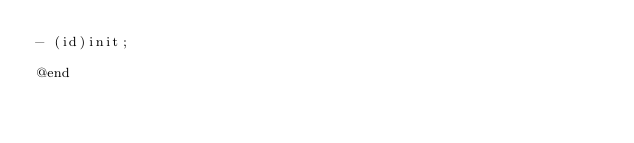Convert code to text. <code><loc_0><loc_0><loc_500><loc_500><_C_>- (id)init;

@end

</code> 